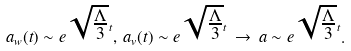<formula> <loc_0><loc_0><loc_500><loc_500>a _ { w } ( t ) \sim e ^ { \sqrt { \frac { \Lambda } { 3 } } t } , \, a _ { v } ( t ) \sim e ^ { \sqrt { \frac { \Lambda } { 3 } } t } \, \rightarrow \, a \sim e ^ { \sqrt { \frac { \Lambda } { 3 } } t } .</formula> 